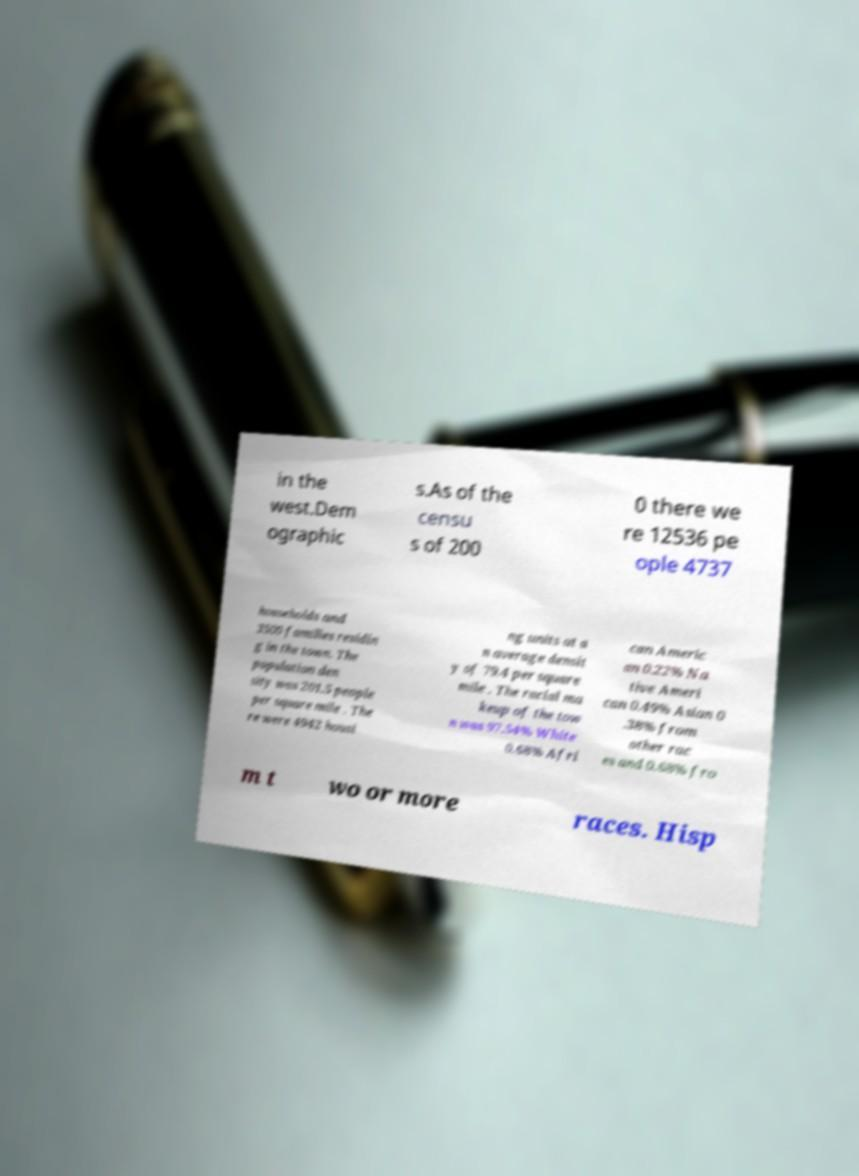Can you accurately transcribe the text from the provided image for me? in the west.Dem ographic s.As of the censu s of 200 0 there we re 12536 pe ople 4737 households and 3500 families residin g in the town. The population den sity was 201.5 people per square mile . The re were 4942 housi ng units at a n average densit y of 79.4 per square mile . The racial ma keup of the tow n was 97.54% White 0.68% Afri can Americ an 0.22% Na tive Ameri can 0.49% Asian 0 .38% from other rac es and 0.68% fro m t wo or more races. Hisp 